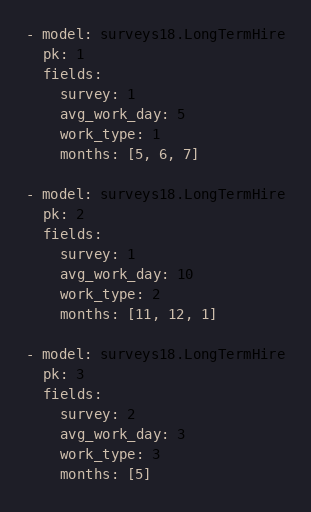<code> <loc_0><loc_0><loc_500><loc_500><_YAML_>- model: surveys18.LongTermHire
  pk: 1
  fields:
    survey: 1
    avg_work_day: 5
    work_type: 1
    months: [5, 6, 7]

- model: surveys18.LongTermHire
  pk: 2
  fields:
    survey: 1
    avg_work_day: 10
    work_type: 2
    months: [11, 12, 1]

- model: surveys18.LongTermHire
  pk: 3
  fields:
    survey: 2
    avg_work_day: 3
    work_type: 3
    months: [5]
</code> 